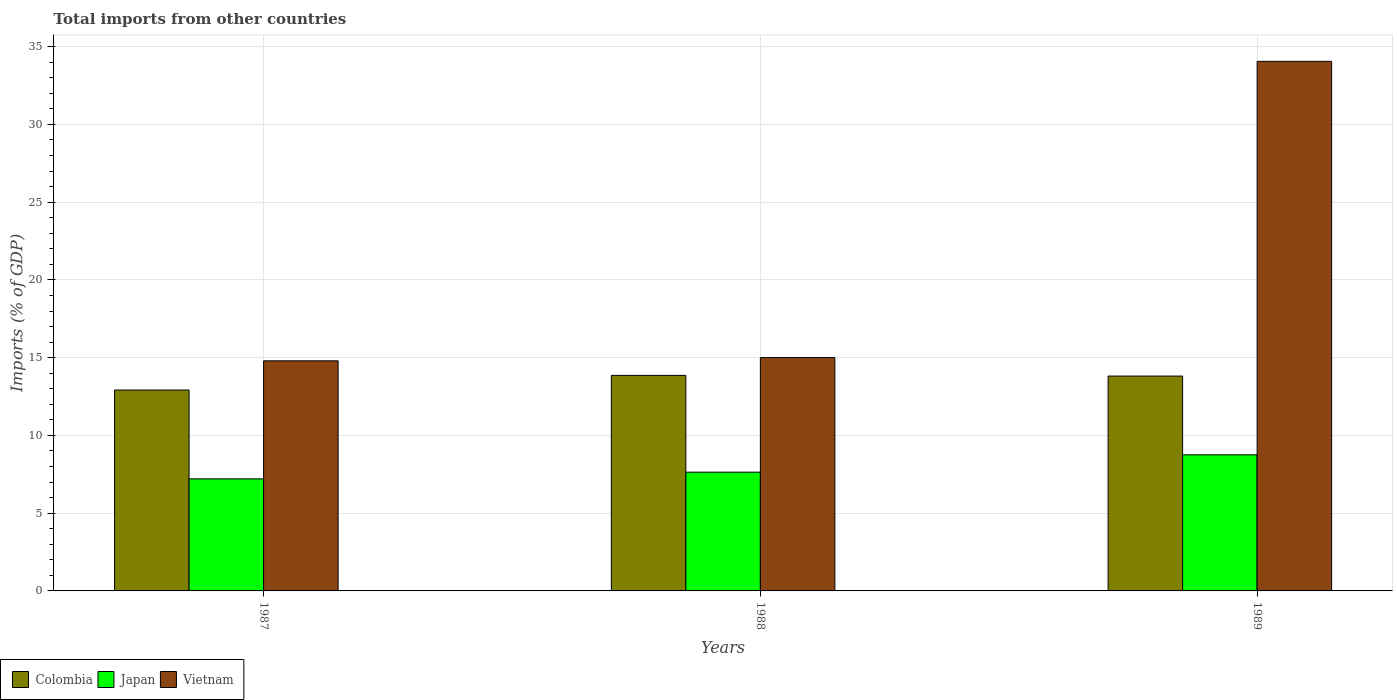Are the number of bars per tick equal to the number of legend labels?
Your answer should be compact. Yes. Are the number of bars on each tick of the X-axis equal?
Your answer should be very brief. Yes. How many bars are there on the 2nd tick from the left?
Offer a terse response. 3. How many bars are there on the 2nd tick from the right?
Offer a terse response. 3. What is the label of the 1st group of bars from the left?
Ensure brevity in your answer.  1987. In how many cases, is the number of bars for a given year not equal to the number of legend labels?
Your answer should be very brief. 0. What is the total imports in Japan in 1987?
Provide a succinct answer. 7.21. Across all years, what is the maximum total imports in Vietnam?
Your response must be concise. 34.06. Across all years, what is the minimum total imports in Colombia?
Provide a short and direct response. 12.92. In which year was the total imports in Vietnam maximum?
Make the answer very short. 1989. In which year was the total imports in Colombia minimum?
Offer a very short reply. 1987. What is the total total imports in Colombia in the graph?
Offer a very short reply. 40.6. What is the difference between the total imports in Japan in 1987 and that in 1989?
Ensure brevity in your answer.  -1.55. What is the difference between the total imports in Japan in 1988 and the total imports in Vietnam in 1989?
Provide a succinct answer. -26.42. What is the average total imports in Vietnam per year?
Your answer should be compact. 21.29. In the year 1987, what is the difference between the total imports in Colombia and total imports in Japan?
Ensure brevity in your answer.  5.71. What is the ratio of the total imports in Japan in 1987 to that in 1989?
Your answer should be compact. 0.82. What is the difference between the highest and the second highest total imports in Colombia?
Ensure brevity in your answer.  0.04. What is the difference between the highest and the lowest total imports in Japan?
Keep it short and to the point. 1.55. Is the sum of the total imports in Colombia in 1987 and 1988 greater than the maximum total imports in Vietnam across all years?
Keep it short and to the point. No. What does the 3rd bar from the left in 1987 represents?
Keep it short and to the point. Vietnam. What does the 1st bar from the right in 1987 represents?
Provide a succinct answer. Vietnam. Is it the case that in every year, the sum of the total imports in Colombia and total imports in Japan is greater than the total imports in Vietnam?
Your response must be concise. No. How many years are there in the graph?
Your answer should be very brief. 3. What is the difference between two consecutive major ticks on the Y-axis?
Provide a succinct answer. 5. Does the graph contain any zero values?
Keep it short and to the point. No. Does the graph contain grids?
Your answer should be very brief. Yes. Where does the legend appear in the graph?
Your answer should be very brief. Bottom left. What is the title of the graph?
Offer a terse response. Total imports from other countries. Does "Hungary" appear as one of the legend labels in the graph?
Provide a short and direct response. No. What is the label or title of the Y-axis?
Your response must be concise. Imports (% of GDP). What is the Imports (% of GDP) of Colombia in 1987?
Ensure brevity in your answer.  12.92. What is the Imports (% of GDP) in Japan in 1987?
Provide a short and direct response. 7.21. What is the Imports (% of GDP) in Vietnam in 1987?
Offer a terse response. 14.8. What is the Imports (% of GDP) of Colombia in 1988?
Ensure brevity in your answer.  13.86. What is the Imports (% of GDP) in Japan in 1988?
Make the answer very short. 7.64. What is the Imports (% of GDP) of Vietnam in 1988?
Provide a succinct answer. 15.01. What is the Imports (% of GDP) in Colombia in 1989?
Your answer should be very brief. 13.82. What is the Imports (% of GDP) of Japan in 1989?
Your answer should be compact. 8.75. What is the Imports (% of GDP) of Vietnam in 1989?
Offer a very short reply. 34.06. Across all years, what is the maximum Imports (% of GDP) in Colombia?
Offer a terse response. 13.86. Across all years, what is the maximum Imports (% of GDP) in Japan?
Your answer should be very brief. 8.75. Across all years, what is the maximum Imports (% of GDP) of Vietnam?
Your response must be concise. 34.06. Across all years, what is the minimum Imports (% of GDP) in Colombia?
Give a very brief answer. 12.92. Across all years, what is the minimum Imports (% of GDP) in Japan?
Give a very brief answer. 7.21. Across all years, what is the minimum Imports (% of GDP) of Vietnam?
Provide a succinct answer. 14.8. What is the total Imports (% of GDP) of Colombia in the graph?
Your answer should be very brief. 40.6. What is the total Imports (% of GDP) of Japan in the graph?
Give a very brief answer. 23.6. What is the total Imports (% of GDP) of Vietnam in the graph?
Keep it short and to the point. 63.86. What is the difference between the Imports (% of GDP) in Colombia in 1987 and that in 1988?
Ensure brevity in your answer.  -0.94. What is the difference between the Imports (% of GDP) in Japan in 1987 and that in 1988?
Make the answer very short. -0.43. What is the difference between the Imports (% of GDP) in Vietnam in 1987 and that in 1988?
Provide a short and direct response. -0.21. What is the difference between the Imports (% of GDP) of Colombia in 1987 and that in 1989?
Provide a succinct answer. -0.9. What is the difference between the Imports (% of GDP) in Japan in 1987 and that in 1989?
Your answer should be very brief. -1.55. What is the difference between the Imports (% of GDP) of Vietnam in 1987 and that in 1989?
Your answer should be compact. -19.26. What is the difference between the Imports (% of GDP) of Colombia in 1988 and that in 1989?
Provide a succinct answer. 0.04. What is the difference between the Imports (% of GDP) in Japan in 1988 and that in 1989?
Offer a very short reply. -1.12. What is the difference between the Imports (% of GDP) of Vietnam in 1988 and that in 1989?
Your response must be concise. -19.05. What is the difference between the Imports (% of GDP) in Colombia in 1987 and the Imports (% of GDP) in Japan in 1988?
Offer a terse response. 5.28. What is the difference between the Imports (% of GDP) in Colombia in 1987 and the Imports (% of GDP) in Vietnam in 1988?
Offer a terse response. -2.09. What is the difference between the Imports (% of GDP) in Japan in 1987 and the Imports (% of GDP) in Vietnam in 1988?
Your answer should be very brief. -7.8. What is the difference between the Imports (% of GDP) of Colombia in 1987 and the Imports (% of GDP) of Japan in 1989?
Your answer should be compact. 4.17. What is the difference between the Imports (% of GDP) in Colombia in 1987 and the Imports (% of GDP) in Vietnam in 1989?
Keep it short and to the point. -21.14. What is the difference between the Imports (% of GDP) in Japan in 1987 and the Imports (% of GDP) in Vietnam in 1989?
Offer a terse response. -26.85. What is the difference between the Imports (% of GDP) of Colombia in 1988 and the Imports (% of GDP) of Japan in 1989?
Offer a very short reply. 5.11. What is the difference between the Imports (% of GDP) in Colombia in 1988 and the Imports (% of GDP) in Vietnam in 1989?
Your response must be concise. -20.19. What is the difference between the Imports (% of GDP) of Japan in 1988 and the Imports (% of GDP) of Vietnam in 1989?
Offer a very short reply. -26.42. What is the average Imports (% of GDP) of Colombia per year?
Provide a succinct answer. 13.53. What is the average Imports (% of GDP) of Japan per year?
Provide a short and direct response. 7.87. What is the average Imports (% of GDP) of Vietnam per year?
Your answer should be very brief. 21.29. In the year 1987, what is the difference between the Imports (% of GDP) in Colombia and Imports (% of GDP) in Japan?
Offer a very short reply. 5.71. In the year 1987, what is the difference between the Imports (% of GDP) of Colombia and Imports (% of GDP) of Vietnam?
Your answer should be very brief. -1.88. In the year 1987, what is the difference between the Imports (% of GDP) of Japan and Imports (% of GDP) of Vietnam?
Keep it short and to the point. -7.59. In the year 1988, what is the difference between the Imports (% of GDP) of Colombia and Imports (% of GDP) of Japan?
Offer a terse response. 6.22. In the year 1988, what is the difference between the Imports (% of GDP) of Colombia and Imports (% of GDP) of Vietnam?
Offer a terse response. -1.14. In the year 1988, what is the difference between the Imports (% of GDP) in Japan and Imports (% of GDP) in Vietnam?
Your response must be concise. -7.37. In the year 1989, what is the difference between the Imports (% of GDP) in Colombia and Imports (% of GDP) in Japan?
Offer a very short reply. 5.06. In the year 1989, what is the difference between the Imports (% of GDP) of Colombia and Imports (% of GDP) of Vietnam?
Ensure brevity in your answer.  -20.24. In the year 1989, what is the difference between the Imports (% of GDP) in Japan and Imports (% of GDP) in Vietnam?
Provide a short and direct response. -25.3. What is the ratio of the Imports (% of GDP) in Colombia in 1987 to that in 1988?
Your answer should be very brief. 0.93. What is the ratio of the Imports (% of GDP) in Japan in 1987 to that in 1988?
Give a very brief answer. 0.94. What is the ratio of the Imports (% of GDP) in Vietnam in 1987 to that in 1988?
Give a very brief answer. 0.99. What is the ratio of the Imports (% of GDP) in Colombia in 1987 to that in 1989?
Your answer should be compact. 0.94. What is the ratio of the Imports (% of GDP) of Japan in 1987 to that in 1989?
Your answer should be very brief. 0.82. What is the ratio of the Imports (% of GDP) of Vietnam in 1987 to that in 1989?
Make the answer very short. 0.43. What is the ratio of the Imports (% of GDP) of Colombia in 1988 to that in 1989?
Give a very brief answer. 1. What is the ratio of the Imports (% of GDP) of Japan in 1988 to that in 1989?
Your answer should be compact. 0.87. What is the ratio of the Imports (% of GDP) of Vietnam in 1988 to that in 1989?
Provide a succinct answer. 0.44. What is the difference between the highest and the second highest Imports (% of GDP) of Colombia?
Your answer should be very brief. 0.04. What is the difference between the highest and the second highest Imports (% of GDP) in Japan?
Give a very brief answer. 1.12. What is the difference between the highest and the second highest Imports (% of GDP) of Vietnam?
Ensure brevity in your answer.  19.05. What is the difference between the highest and the lowest Imports (% of GDP) in Colombia?
Give a very brief answer. 0.94. What is the difference between the highest and the lowest Imports (% of GDP) in Japan?
Make the answer very short. 1.55. What is the difference between the highest and the lowest Imports (% of GDP) of Vietnam?
Provide a short and direct response. 19.26. 